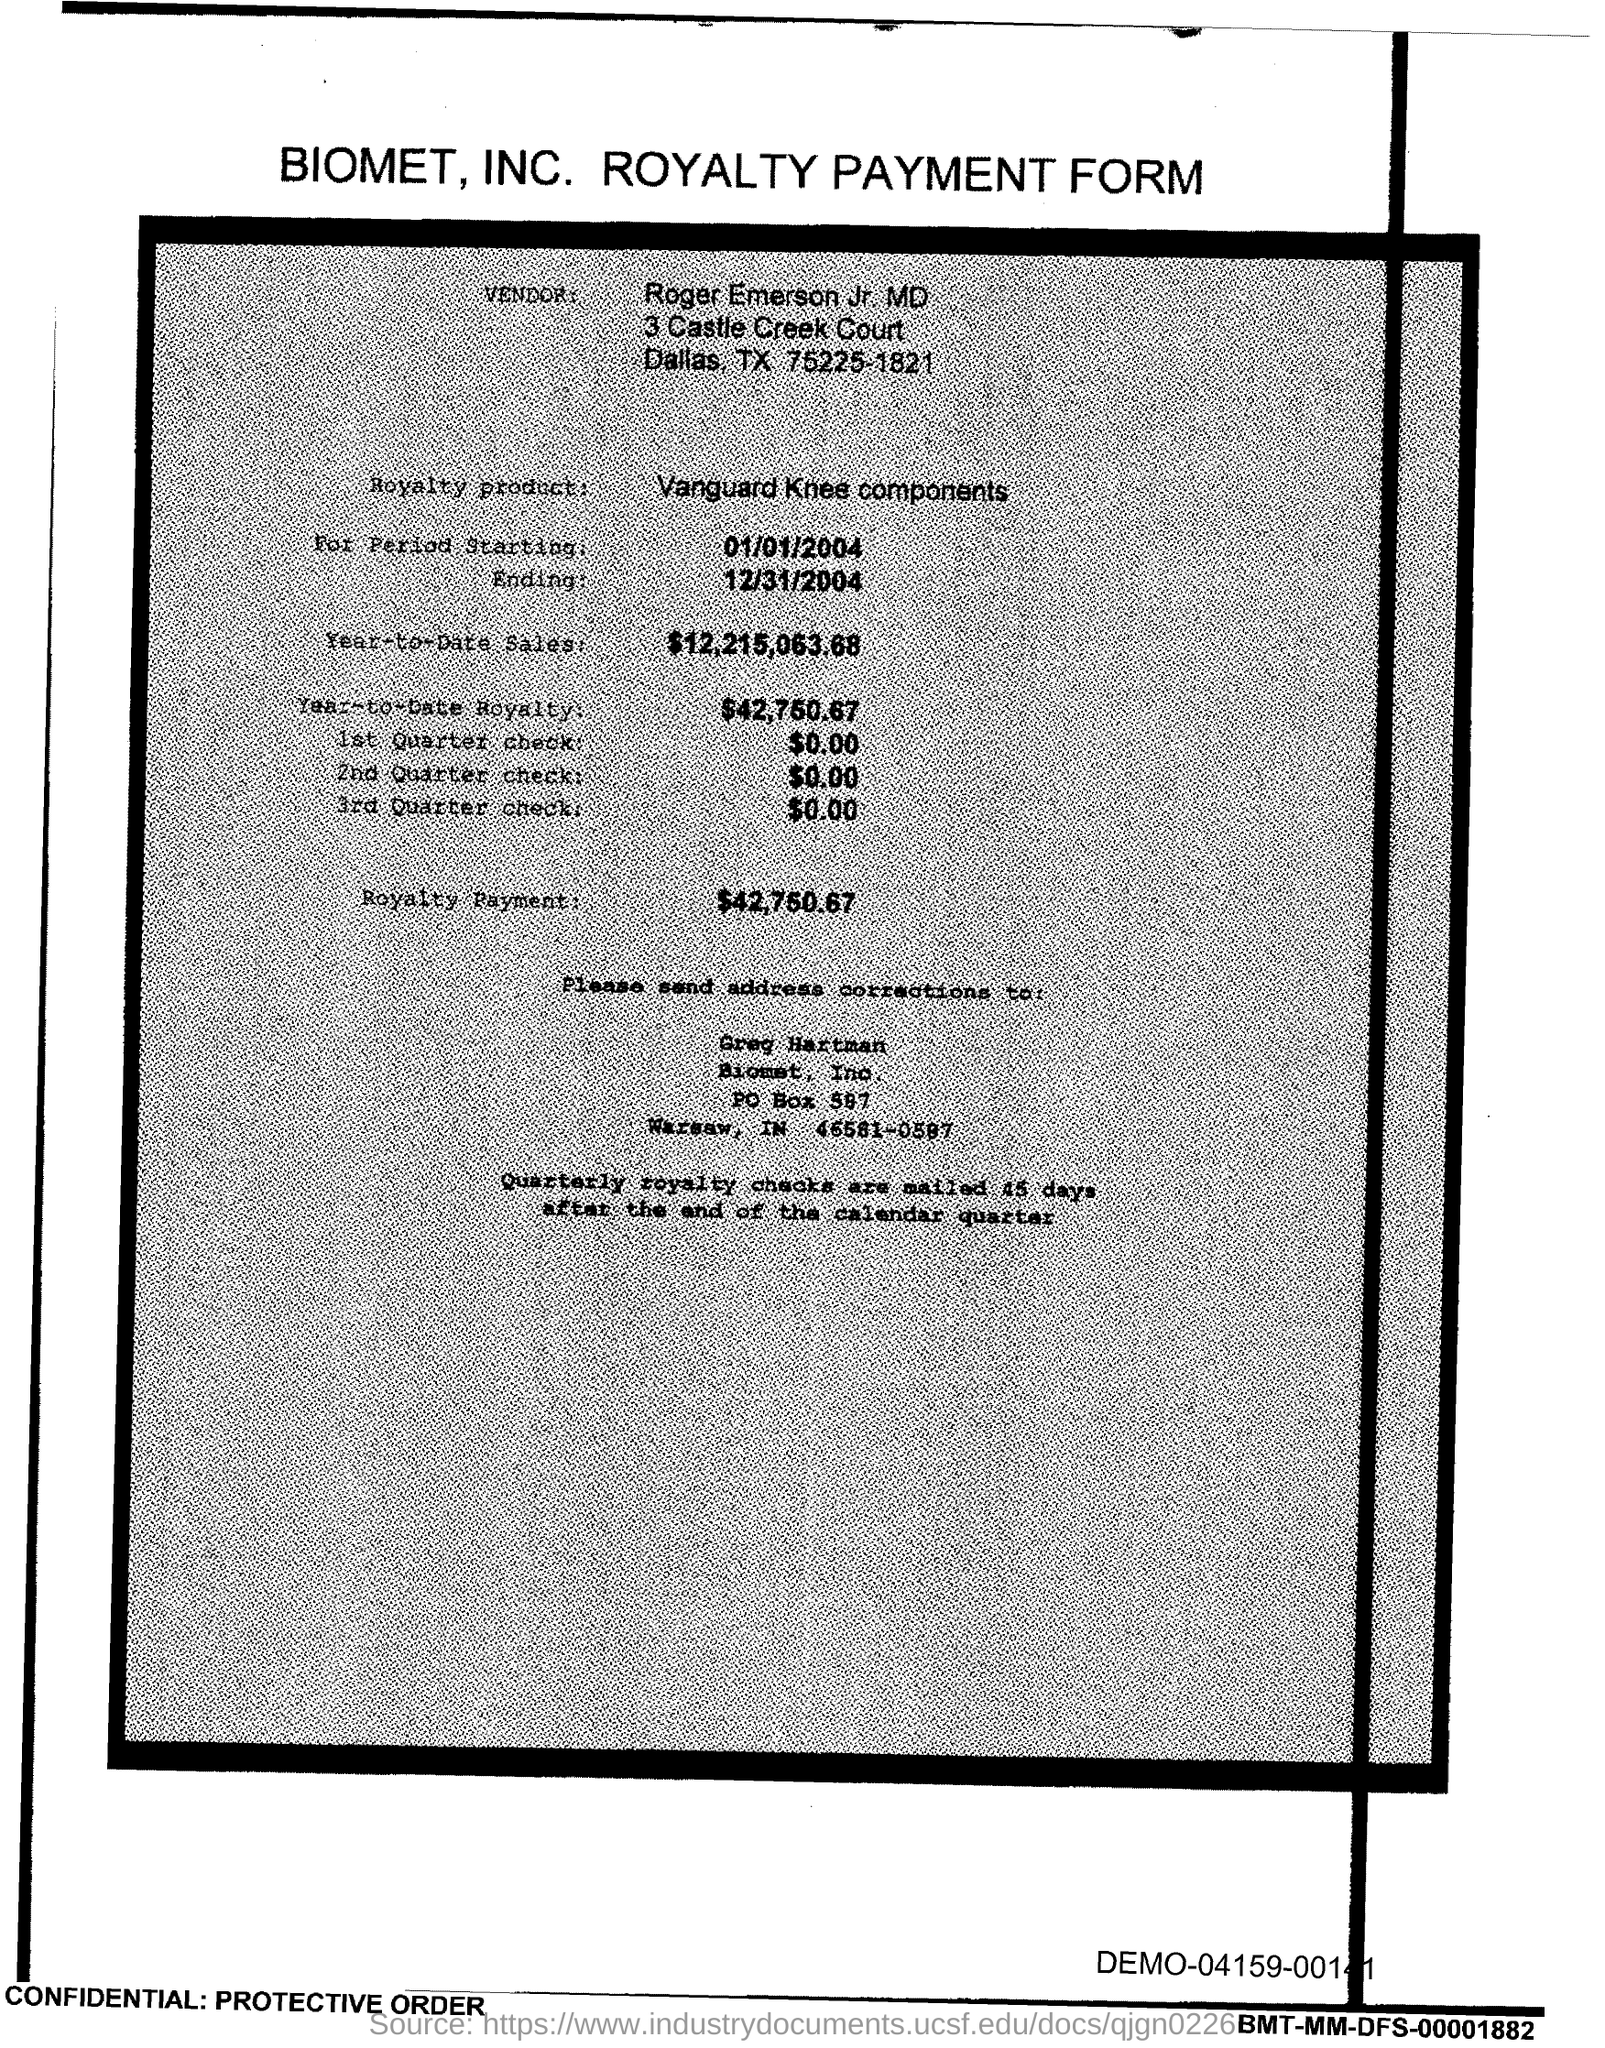What is the vendor name given in the form?
Offer a terse response. Roger Emerson Jr. MD. What is the royalty product given in the form?
Ensure brevity in your answer.  Vanguard Knee components. What is the start date of the royalty period?
Provide a short and direct response. 01/01/2004. What is the Year-to-Date Sales of the royalty product?
Provide a short and direct response. 12,215,063.68. What is the amount of 1st quarter check mentioned in the form?
Your response must be concise. $0.00. What is the amount of 2nd Quarter check mentioned in the form?
Keep it short and to the point. $0.00. What is the end date of the royalty period?
Make the answer very short. 12/31/2004. Who is responsible to do the address corrections?
Offer a terse response. Greg Hartman. 